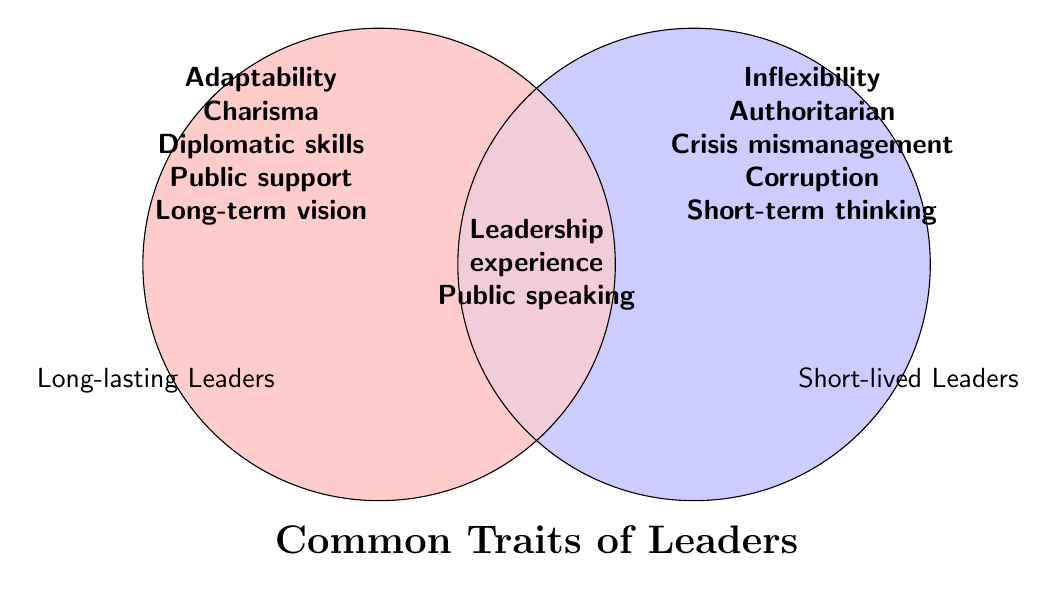What are the common traits shared by both long-lasting and short-lived leaders? Common traits are found in the overlapping section of the Venn diagram which are Leadership experience and Public speaking skills.
Answer: Leadership experience and Public speaking skills Which trait is unique to long-lasting leaders but not found in short-lived leaders? This requires looking at the section of the Venn diagram only for long-lasting leaders. The unique traits are Adaptability, Charisma, Strong diplomatic skills, Consistent public support, and Clear long-term vision.
Answer: Adaptability, Charisma, Strong diplomatic skills, Consistent public support, Clear long-term vision Identify a trait that is unique to short-lived leaders. This requires looking at the section of the Venn diagram only for short-lived leaders. The unique traits are Inflexibility, Authoritarian tendencies, Inability to handle crises, Corruption scandals, and Short-term thinking.
Answer: Inflexibility, Authoritarian tendencies, Inability to handle crises, Corruption scandals, Short-term thinking How many more unique traits do long-lasting leaders have compared to short-lived leaders? Long-lasting leaders have 5 unique traits (Adaptability, Charisma, Strong diplomatic skills, Consistent public support, and Clear long-term vision) and short-lived leaders also have 5 unique traits (Inflexibility, Authoritarian tendencies, Inability to handle crises, Corruption scandals, Short-term thinking). 5 - 5 = 0
Answer: 0 What trait among short-lived leaders might directly oppose strong diplomatic skills in long-lasting leaders? To find opposing traits, one should contrast the traits of the two groups. Strong diplomatic skills could be opposed by Inability to handle crises in short-lived leaders.
Answer: Inability to handle crises Of the two leader types, which group is characterized by Authoritarian tendencies? This can be identified by looking at the traits listed exclusively in the short-lived leaders section. Authoritarian tendencies is listed there.
Answer: Short-lived leaders Which section of the diagram contains traits that may contribute to a leader having consistent public support? This can be reasoned by looking at traits in the long-lasting leader's section. Traits like Charisma and Strong diplomatic skills could contribute to Consistent public support.
Answer: Long-lasting leaders Would you consider public speaking skills a more crucial trait for both types of leaders? This can be identified by the overlap in the Venn diagram where public speaking skills are present in the common area.
Answer: Yes What indicates short-lived leaders have traits making them more prone to scandals? This is evident in the unique traits section for short-lived leaders, which lists Corruption scandals.
Answer: Corruption scandals 